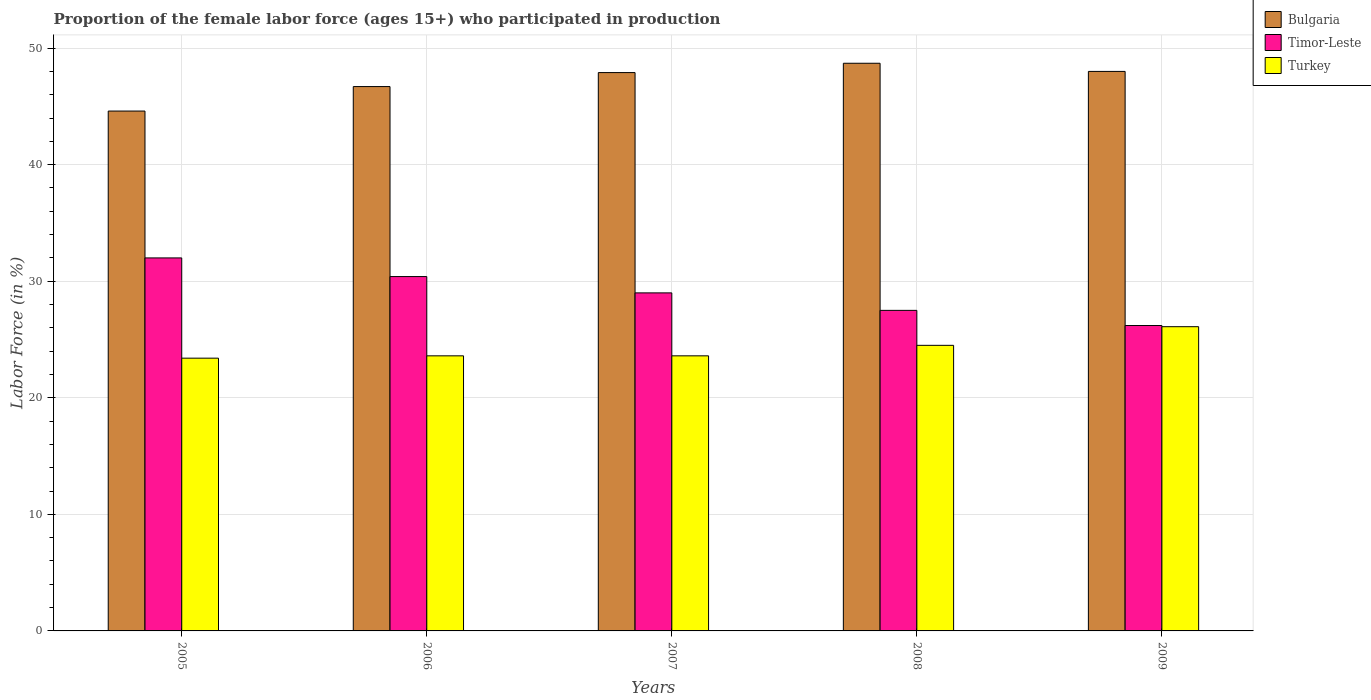How many different coloured bars are there?
Make the answer very short. 3. Are the number of bars per tick equal to the number of legend labels?
Keep it short and to the point. Yes. Are the number of bars on each tick of the X-axis equal?
Your answer should be compact. Yes. How many bars are there on the 5th tick from the left?
Keep it short and to the point. 3. How many bars are there on the 4th tick from the right?
Give a very brief answer. 3. What is the label of the 2nd group of bars from the left?
Offer a very short reply. 2006. In how many cases, is the number of bars for a given year not equal to the number of legend labels?
Keep it short and to the point. 0. What is the proportion of the female labor force who participated in production in Turkey in 2005?
Ensure brevity in your answer.  23.4. Across all years, what is the maximum proportion of the female labor force who participated in production in Bulgaria?
Your response must be concise. 48.7. Across all years, what is the minimum proportion of the female labor force who participated in production in Timor-Leste?
Provide a short and direct response. 26.2. What is the total proportion of the female labor force who participated in production in Bulgaria in the graph?
Offer a terse response. 235.9. What is the difference between the proportion of the female labor force who participated in production in Turkey in 2005 and that in 2008?
Your answer should be compact. -1.1. What is the difference between the proportion of the female labor force who participated in production in Bulgaria in 2008 and the proportion of the female labor force who participated in production in Timor-Leste in 2009?
Give a very brief answer. 22.5. What is the average proportion of the female labor force who participated in production in Bulgaria per year?
Your answer should be compact. 47.18. In the year 2007, what is the difference between the proportion of the female labor force who participated in production in Bulgaria and proportion of the female labor force who participated in production in Timor-Leste?
Your answer should be compact. 18.9. In how many years, is the proportion of the female labor force who participated in production in Timor-Leste greater than 24 %?
Your answer should be compact. 5. What is the ratio of the proportion of the female labor force who participated in production in Bulgaria in 2005 to that in 2009?
Keep it short and to the point. 0.93. Is the proportion of the female labor force who participated in production in Turkey in 2008 less than that in 2009?
Provide a succinct answer. Yes. Is the difference between the proportion of the female labor force who participated in production in Bulgaria in 2005 and 2008 greater than the difference between the proportion of the female labor force who participated in production in Timor-Leste in 2005 and 2008?
Your answer should be compact. No. What is the difference between the highest and the second highest proportion of the female labor force who participated in production in Bulgaria?
Your answer should be very brief. 0.7. What is the difference between the highest and the lowest proportion of the female labor force who participated in production in Timor-Leste?
Provide a succinct answer. 5.8. In how many years, is the proportion of the female labor force who participated in production in Timor-Leste greater than the average proportion of the female labor force who participated in production in Timor-Leste taken over all years?
Your response must be concise. 2. What does the 2nd bar from the right in 2008 represents?
Keep it short and to the point. Timor-Leste. How many bars are there?
Provide a short and direct response. 15. Are all the bars in the graph horizontal?
Offer a very short reply. No. What is the difference between two consecutive major ticks on the Y-axis?
Your answer should be compact. 10. How many legend labels are there?
Offer a very short reply. 3. How are the legend labels stacked?
Offer a terse response. Vertical. What is the title of the graph?
Offer a terse response. Proportion of the female labor force (ages 15+) who participated in production. What is the Labor Force (in %) in Bulgaria in 2005?
Keep it short and to the point. 44.6. What is the Labor Force (in %) of Turkey in 2005?
Your answer should be compact. 23.4. What is the Labor Force (in %) in Bulgaria in 2006?
Make the answer very short. 46.7. What is the Labor Force (in %) in Timor-Leste in 2006?
Your response must be concise. 30.4. What is the Labor Force (in %) in Turkey in 2006?
Provide a succinct answer. 23.6. What is the Labor Force (in %) in Bulgaria in 2007?
Keep it short and to the point. 47.9. What is the Labor Force (in %) of Turkey in 2007?
Your response must be concise. 23.6. What is the Labor Force (in %) of Bulgaria in 2008?
Your answer should be very brief. 48.7. What is the Labor Force (in %) in Timor-Leste in 2008?
Offer a terse response. 27.5. What is the Labor Force (in %) in Turkey in 2008?
Provide a short and direct response. 24.5. What is the Labor Force (in %) in Bulgaria in 2009?
Your answer should be very brief. 48. What is the Labor Force (in %) of Timor-Leste in 2009?
Provide a succinct answer. 26.2. What is the Labor Force (in %) in Turkey in 2009?
Give a very brief answer. 26.1. Across all years, what is the maximum Labor Force (in %) in Bulgaria?
Your answer should be compact. 48.7. Across all years, what is the maximum Labor Force (in %) of Timor-Leste?
Provide a succinct answer. 32. Across all years, what is the maximum Labor Force (in %) of Turkey?
Provide a succinct answer. 26.1. Across all years, what is the minimum Labor Force (in %) in Bulgaria?
Your answer should be very brief. 44.6. Across all years, what is the minimum Labor Force (in %) in Timor-Leste?
Ensure brevity in your answer.  26.2. Across all years, what is the minimum Labor Force (in %) of Turkey?
Provide a short and direct response. 23.4. What is the total Labor Force (in %) in Bulgaria in the graph?
Your response must be concise. 235.9. What is the total Labor Force (in %) of Timor-Leste in the graph?
Ensure brevity in your answer.  145.1. What is the total Labor Force (in %) of Turkey in the graph?
Your response must be concise. 121.2. What is the difference between the Labor Force (in %) in Timor-Leste in 2005 and that in 2006?
Ensure brevity in your answer.  1.6. What is the difference between the Labor Force (in %) in Bulgaria in 2005 and that in 2007?
Keep it short and to the point. -3.3. What is the difference between the Labor Force (in %) in Timor-Leste in 2005 and that in 2007?
Give a very brief answer. 3. What is the difference between the Labor Force (in %) in Turkey in 2005 and that in 2008?
Keep it short and to the point. -1.1. What is the difference between the Labor Force (in %) in Turkey in 2005 and that in 2009?
Offer a very short reply. -2.7. What is the difference between the Labor Force (in %) of Bulgaria in 2006 and that in 2007?
Provide a succinct answer. -1.2. What is the difference between the Labor Force (in %) of Turkey in 2006 and that in 2007?
Offer a terse response. 0. What is the difference between the Labor Force (in %) of Bulgaria in 2006 and that in 2008?
Keep it short and to the point. -2. What is the difference between the Labor Force (in %) of Turkey in 2006 and that in 2008?
Offer a terse response. -0.9. What is the difference between the Labor Force (in %) of Timor-Leste in 2006 and that in 2009?
Offer a very short reply. 4.2. What is the difference between the Labor Force (in %) in Turkey in 2007 and that in 2008?
Your answer should be very brief. -0.9. What is the difference between the Labor Force (in %) in Bulgaria in 2007 and that in 2009?
Make the answer very short. -0.1. What is the difference between the Labor Force (in %) of Turkey in 2007 and that in 2009?
Give a very brief answer. -2.5. What is the difference between the Labor Force (in %) of Bulgaria in 2008 and that in 2009?
Your answer should be very brief. 0.7. What is the difference between the Labor Force (in %) in Timor-Leste in 2008 and that in 2009?
Offer a very short reply. 1.3. What is the difference between the Labor Force (in %) in Turkey in 2008 and that in 2009?
Offer a terse response. -1.6. What is the difference between the Labor Force (in %) of Bulgaria in 2005 and the Labor Force (in %) of Timor-Leste in 2006?
Provide a succinct answer. 14.2. What is the difference between the Labor Force (in %) in Bulgaria in 2005 and the Labor Force (in %) in Turkey in 2006?
Your answer should be compact. 21. What is the difference between the Labor Force (in %) in Timor-Leste in 2005 and the Labor Force (in %) in Turkey in 2006?
Provide a short and direct response. 8.4. What is the difference between the Labor Force (in %) of Bulgaria in 2005 and the Labor Force (in %) of Timor-Leste in 2007?
Give a very brief answer. 15.6. What is the difference between the Labor Force (in %) of Timor-Leste in 2005 and the Labor Force (in %) of Turkey in 2007?
Offer a terse response. 8.4. What is the difference between the Labor Force (in %) of Bulgaria in 2005 and the Labor Force (in %) of Turkey in 2008?
Keep it short and to the point. 20.1. What is the difference between the Labor Force (in %) of Timor-Leste in 2005 and the Labor Force (in %) of Turkey in 2008?
Provide a short and direct response. 7.5. What is the difference between the Labor Force (in %) in Bulgaria in 2005 and the Labor Force (in %) in Turkey in 2009?
Keep it short and to the point. 18.5. What is the difference between the Labor Force (in %) in Timor-Leste in 2005 and the Labor Force (in %) in Turkey in 2009?
Your answer should be very brief. 5.9. What is the difference between the Labor Force (in %) in Bulgaria in 2006 and the Labor Force (in %) in Turkey in 2007?
Your answer should be very brief. 23.1. What is the difference between the Labor Force (in %) of Timor-Leste in 2006 and the Labor Force (in %) of Turkey in 2008?
Offer a terse response. 5.9. What is the difference between the Labor Force (in %) of Bulgaria in 2006 and the Labor Force (in %) of Timor-Leste in 2009?
Your answer should be compact. 20.5. What is the difference between the Labor Force (in %) in Bulgaria in 2006 and the Labor Force (in %) in Turkey in 2009?
Keep it short and to the point. 20.6. What is the difference between the Labor Force (in %) of Bulgaria in 2007 and the Labor Force (in %) of Timor-Leste in 2008?
Keep it short and to the point. 20.4. What is the difference between the Labor Force (in %) of Bulgaria in 2007 and the Labor Force (in %) of Turkey in 2008?
Your response must be concise. 23.4. What is the difference between the Labor Force (in %) in Bulgaria in 2007 and the Labor Force (in %) in Timor-Leste in 2009?
Offer a very short reply. 21.7. What is the difference between the Labor Force (in %) in Bulgaria in 2007 and the Labor Force (in %) in Turkey in 2009?
Your answer should be compact. 21.8. What is the difference between the Labor Force (in %) of Bulgaria in 2008 and the Labor Force (in %) of Timor-Leste in 2009?
Keep it short and to the point. 22.5. What is the difference between the Labor Force (in %) in Bulgaria in 2008 and the Labor Force (in %) in Turkey in 2009?
Ensure brevity in your answer.  22.6. What is the average Labor Force (in %) of Bulgaria per year?
Provide a short and direct response. 47.18. What is the average Labor Force (in %) of Timor-Leste per year?
Keep it short and to the point. 29.02. What is the average Labor Force (in %) in Turkey per year?
Your answer should be very brief. 24.24. In the year 2005, what is the difference between the Labor Force (in %) in Bulgaria and Labor Force (in %) in Timor-Leste?
Your answer should be compact. 12.6. In the year 2005, what is the difference between the Labor Force (in %) in Bulgaria and Labor Force (in %) in Turkey?
Give a very brief answer. 21.2. In the year 2006, what is the difference between the Labor Force (in %) in Bulgaria and Labor Force (in %) in Turkey?
Your response must be concise. 23.1. In the year 2006, what is the difference between the Labor Force (in %) in Timor-Leste and Labor Force (in %) in Turkey?
Offer a terse response. 6.8. In the year 2007, what is the difference between the Labor Force (in %) in Bulgaria and Labor Force (in %) in Turkey?
Your response must be concise. 24.3. In the year 2008, what is the difference between the Labor Force (in %) of Bulgaria and Labor Force (in %) of Timor-Leste?
Ensure brevity in your answer.  21.2. In the year 2008, what is the difference between the Labor Force (in %) of Bulgaria and Labor Force (in %) of Turkey?
Make the answer very short. 24.2. In the year 2009, what is the difference between the Labor Force (in %) in Bulgaria and Labor Force (in %) in Timor-Leste?
Your answer should be very brief. 21.8. In the year 2009, what is the difference between the Labor Force (in %) of Bulgaria and Labor Force (in %) of Turkey?
Your answer should be compact. 21.9. What is the ratio of the Labor Force (in %) of Bulgaria in 2005 to that in 2006?
Give a very brief answer. 0.95. What is the ratio of the Labor Force (in %) of Timor-Leste in 2005 to that in 2006?
Provide a short and direct response. 1.05. What is the ratio of the Labor Force (in %) of Bulgaria in 2005 to that in 2007?
Offer a very short reply. 0.93. What is the ratio of the Labor Force (in %) of Timor-Leste in 2005 to that in 2007?
Your answer should be very brief. 1.1. What is the ratio of the Labor Force (in %) of Turkey in 2005 to that in 2007?
Offer a terse response. 0.99. What is the ratio of the Labor Force (in %) of Bulgaria in 2005 to that in 2008?
Your answer should be compact. 0.92. What is the ratio of the Labor Force (in %) in Timor-Leste in 2005 to that in 2008?
Make the answer very short. 1.16. What is the ratio of the Labor Force (in %) of Turkey in 2005 to that in 2008?
Provide a succinct answer. 0.96. What is the ratio of the Labor Force (in %) of Bulgaria in 2005 to that in 2009?
Provide a succinct answer. 0.93. What is the ratio of the Labor Force (in %) in Timor-Leste in 2005 to that in 2009?
Provide a short and direct response. 1.22. What is the ratio of the Labor Force (in %) in Turkey in 2005 to that in 2009?
Your response must be concise. 0.9. What is the ratio of the Labor Force (in %) of Bulgaria in 2006 to that in 2007?
Your response must be concise. 0.97. What is the ratio of the Labor Force (in %) of Timor-Leste in 2006 to that in 2007?
Offer a very short reply. 1.05. What is the ratio of the Labor Force (in %) in Turkey in 2006 to that in 2007?
Ensure brevity in your answer.  1. What is the ratio of the Labor Force (in %) in Bulgaria in 2006 to that in 2008?
Keep it short and to the point. 0.96. What is the ratio of the Labor Force (in %) in Timor-Leste in 2006 to that in 2008?
Your answer should be very brief. 1.11. What is the ratio of the Labor Force (in %) in Turkey in 2006 to that in 2008?
Keep it short and to the point. 0.96. What is the ratio of the Labor Force (in %) of Bulgaria in 2006 to that in 2009?
Provide a succinct answer. 0.97. What is the ratio of the Labor Force (in %) of Timor-Leste in 2006 to that in 2009?
Ensure brevity in your answer.  1.16. What is the ratio of the Labor Force (in %) in Turkey in 2006 to that in 2009?
Offer a very short reply. 0.9. What is the ratio of the Labor Force (in %) in Bulgaria in 2007 to that in 2008?
Ensure brevity in your answer.  0.98. What is the ratio of the Labor Force (in %) of Timor-Leste in 2007 to that in 2008?
Your response must be concise. 1.05. What is the ratio of the Labor Force (in %) in Turkey in 2007 to that in 2008?
Ensure brevity in your answer.  0.96. What is the ratio of the Labor Force (in %) in Timor-Leste in 2007 to that in 2009?
Keep it short and to the point. 1.11. What is the ratio of the Labor Force (in %) of Turkey in 2007 to that in 2009?
Offer a very short reply. 0.9. What is the ratio of the Labor Force (in %) in Bulgaria in 2008 to that in 2009?
Your response must be concise. 1.01. What is the ratio of the Labor Force (in %) of Timor-Leste in 2008 to that in 2009?
Your answer should be compact. 1.05. What is the ratio of the Labor Force (in %) of Turkey in 2008 to that in 2009?
Your answer should be very brief. 0.94. What is the difference between the highest and the second highest Labor Force (in %) in Bulgaria?
Your response must be concise. 0.7. What is the difference between the highest and the second highest Labor Force (in %) of Timor-Leste?
Offer a terse response. 1.6. What is the difference between the highest and the second highest Labor Force (in %) of Turkey?
Provide a succinct answer. 1.6. What is the difference between the highest and the lowest Labor Force (in %) in Bulgaria?
Your answer should be compact. 4.1. What is the difference between the highest and the lowest Labor Force (in %) of Timor-Leste?
Provide a short and direct response. 5.8. 